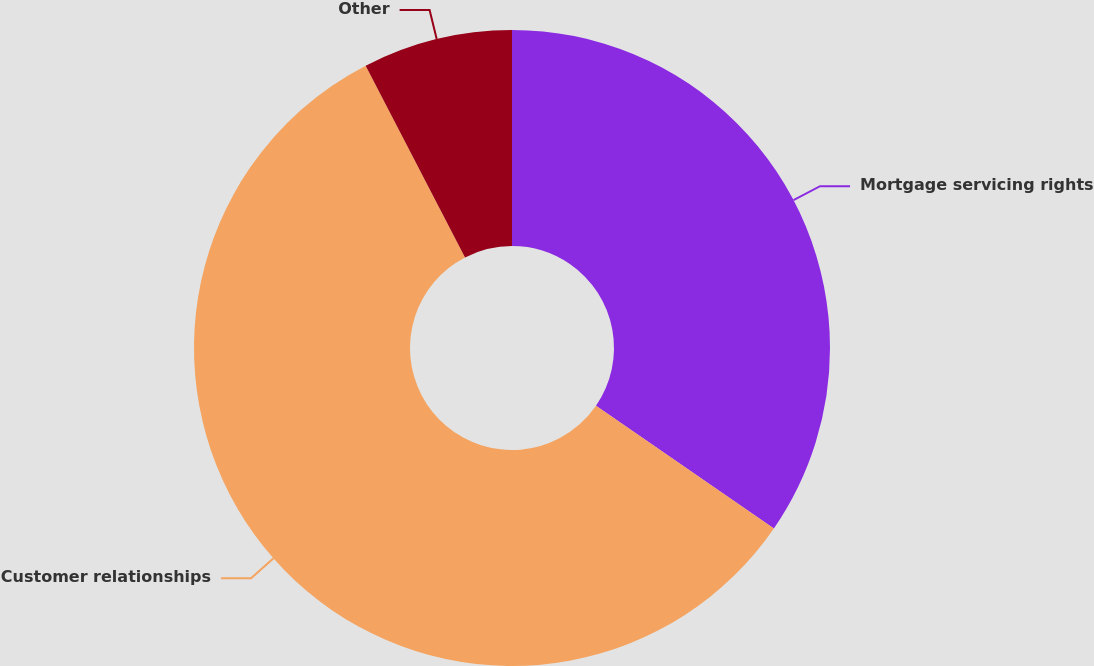Convert chart to OTSL. <chart><loc_0><loc_0><loc_500><loc_500><pie_chart><fcel>Mortgage servicing rights<fcel>Customer relationships<fcel>Other<nl><fcel>34.6%<fcel>57.79%<fcel>7.61%<nl></chart> 